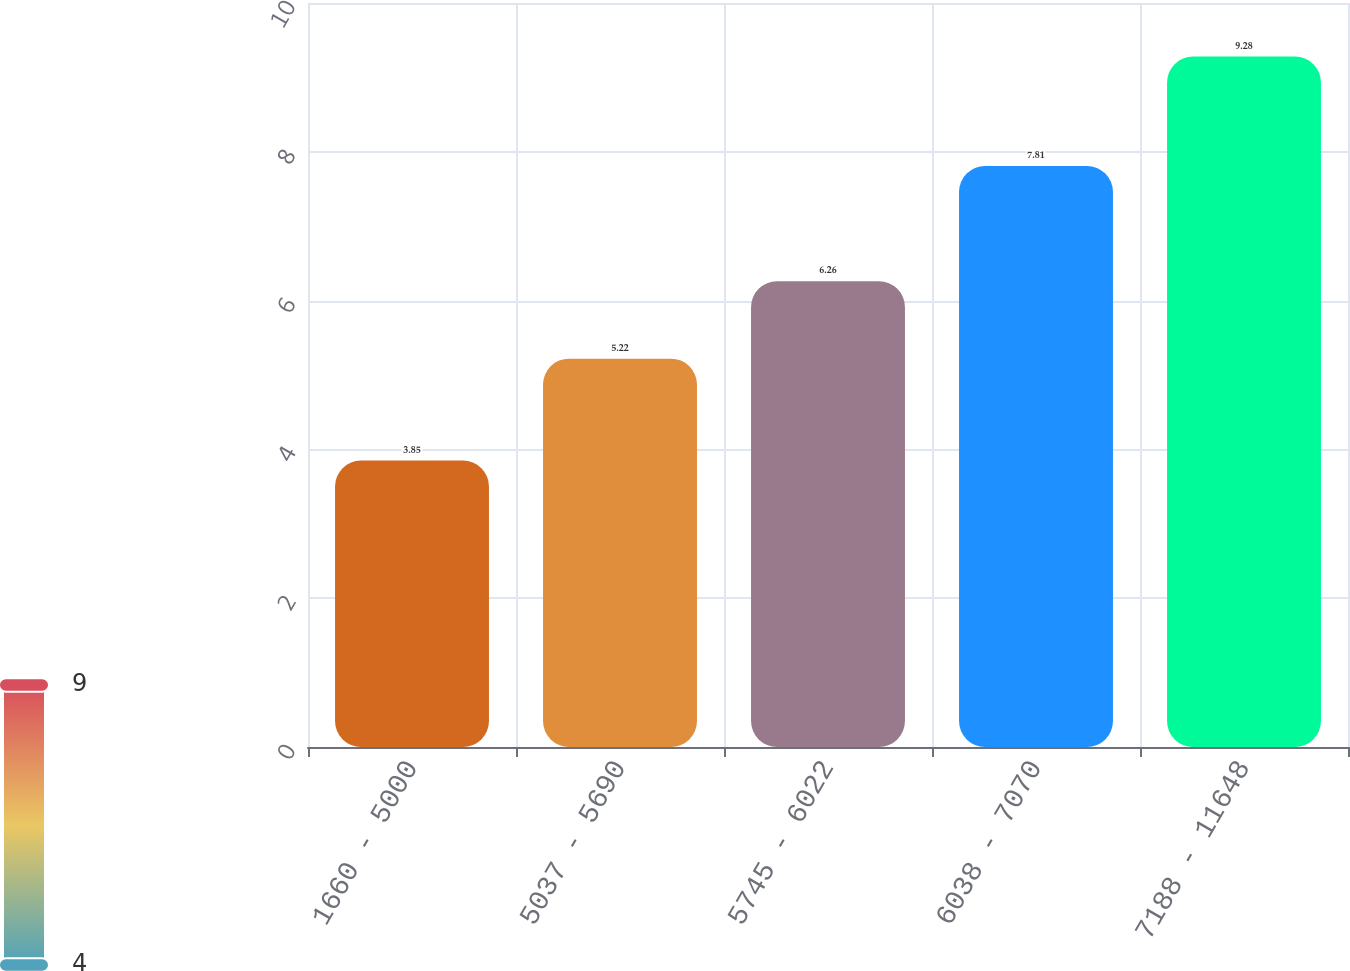<chart> <loc_0><loc_0><loc_500><loc_500><bar_chart><fcel>1660 - 5000<fcel>5037 - 5690<fcel>5745 - 6022<fcel>6038 - 7070<fcel>7188 - 11648<nl><fcel>3.85<fcel>5.22<fcel>6.26<fcel>7.81<fcel>9.28<nl></chart> 